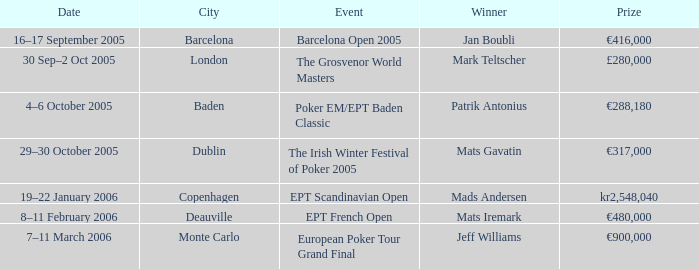What event did Mark Teltscher win? The Grosvenor World Masters. 